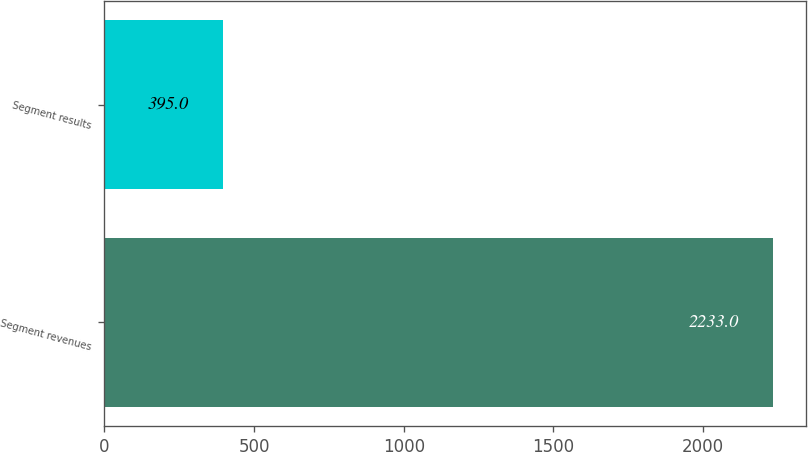<chart> <loc_0><loc_0><loc_500><loc_500><bar_chart><fcel>Segment revenues<fcel>Segment results<nl><fcel>2233<fcel>395<nl></chart> 